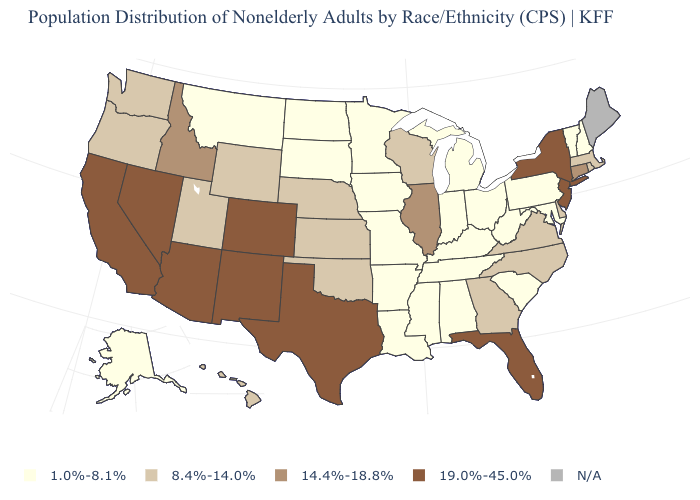Among the states that border California , which have the highest value?
Write a very short answer. Arizona, Nevada. What is the value of Missouri?
Concise answer only. 1.0%-8.1%. Which states have the highest value in the USA?
Short answer required. Arizona, California, Colorado, Florida, Nevada, New Jersey, New Mexico, New York, Texas. What is the value of Nevada?
Quick response, please. 19.0%-45.0%. Name the states that have a value in the range 1.0%-8.1%?
Answer briefly. Alabama, Alaska, Arkansas, Indiana, Iowa, Kentucky, Louisiana, Maryland, Michigan, Minnesota, Mississippi, Missouri, Montana, New Hampshire, North Dakota, Ohio, Pennsylvania, South Carolina, South Dakota, Tennessee, Vermont, West Virginia. Among the states that border Tennessee , which have the highest value?
Keep it brief. Georgia, North Carolina, Virginia. Name the states that have a value in the range N/A?
Give a very brief answer. Maine. Does Florida have the highest value in the USA?
Concise answer only. Yes. Does the map have missing data?
Answer briefly. Yes. Which states hav the highest value in the South?
Give a very brief answer. Florida, Texas. What is the value of Nevada?
Short answer required. 19.0%-45.0%. Which states hav the highest value in the Northeast?
Write a very short answer. New Jersey, New York. Name the states that have a value in the range 19.0%-45.0%?
Concise answer only. Arizona, California, Colorado, Florida, Nevada, New Jersey, New Mexico, New York, Texas. What is the value of Ohio?
Concise answer only. 1.0%-8.1%. What is the value of Louisiana?
Be succinct. 1.0%-8.1%. 